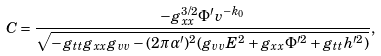<formula> <loc_0><loc_0><loc_500><loc_500>C = \frac { - g _ { x x } ^ { 3 / 2 } \Phi ^ { \prime } v ^ { - k _ { 0 } } } { \sqrt { - g _ { t t } g _ { x x } g _ { v v } - ( 2 \pi \alpha ^ { \prime } ) ^ { 2 } ( g _ { v v } E ^ { 2 } + g _ { x x } \Phi ^ { \prime 2 } + g _ { t t } h ^ { \prime 2 } ) } } ,</formula> 